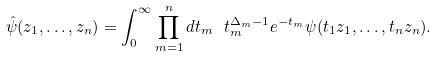<formula> <loc_0><loc_0><loc_500><loc_500>\hat { \psi } ( z _ { 1 } , \dots , z _ { n } ) = \int _ { 0 } ^ { \infty } \prod _ { m = 1 } ^ { n } d t _ { m } \ t _ { m } ^ { \Delta _ { m } - 1 } e ^ { - t _ { m } } \psi ( t _ { 1 } z _ { 1 } , \dots , t _ { n } z _ { n } ) .</formula> 